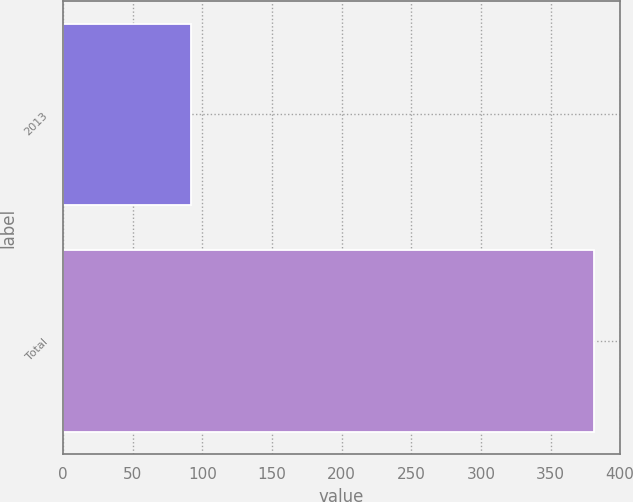<chart> <loc_0><loc_0><loc_500><loc_500><bar_chart><fcel>2013<fcel>Total<nl><fcel>91.7<fcel>381<nl></chart> 